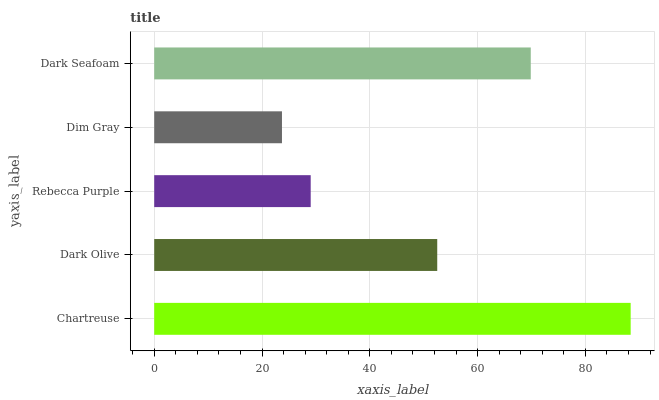Is Dim Gray the minimum?
Answer yes or no. Yes. Is Chartreuse the maximum?
Answer yes or no. Yes. Is Dark Olive the minimum?
Answer yes or no. No. Is Dark Olive the maximum?
Answer yes or no. No. Is Chartreuse greater than Dark Olive?
Answer yes or no. Yes. Is Dark Olive less than Chartreuse?
Answer yes or no. Yes. Is Dark Olive greater than Chartreuse?
Answer yes or no. No. Is Chartreuse less than Dark Olive?
Answer yes or no. No. Is Dark Olive the high median?
Answer yes or no. Yes. Is Dark Olive the low median?
Answer yes or no. Yes. Is Chartreuse the high median?
Answer yes or no. No. Is Dark Seafoam the low median?
Answer yes or no. No. 